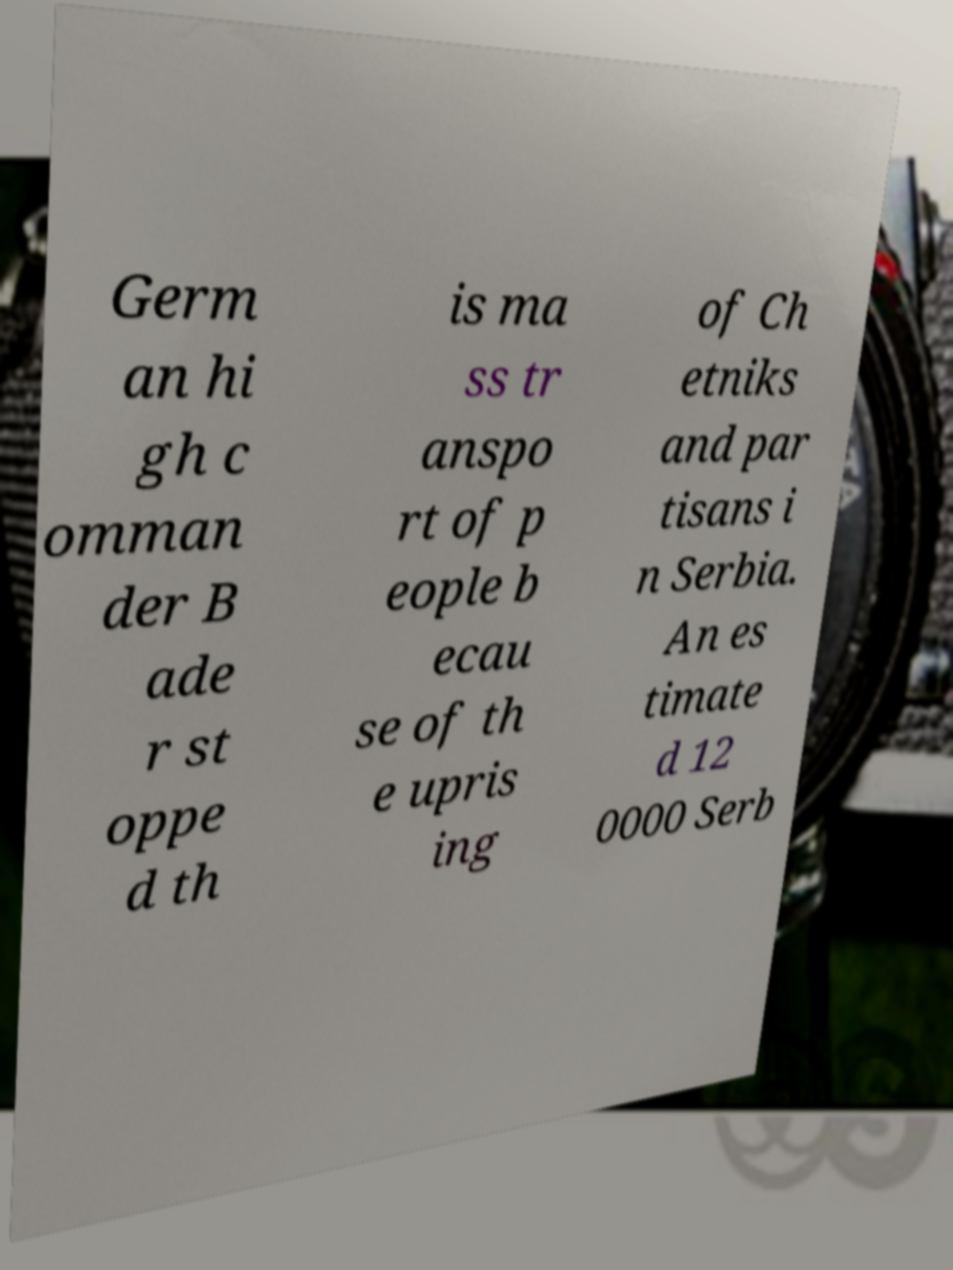For documentation purposes, I need the text within this image transcribed. Could you provide that? Germ an hi gh c omman der B ade r st oppe d th is ma ss tr anspo rt of p eople b ecau se of th e upris ing of Ch etniks and par tisans i n Serbia. An es timate d 12 0000 Serb 